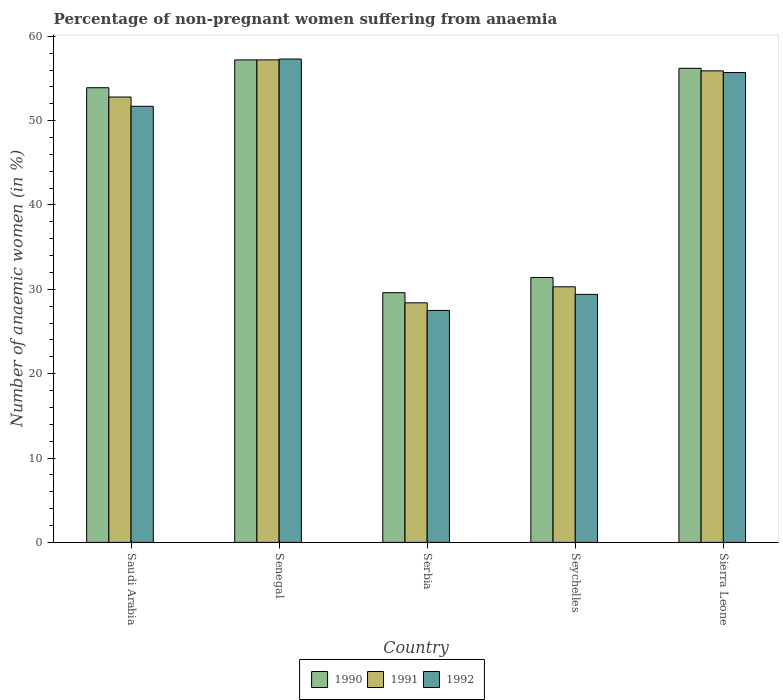Are the number of bars per tick equal to the number of legend labels?
Your response must be concise. Yes. How many bars are there on the 5th tick from the left?
Offer a very short reply. 3. How many bars are there on the 2nd tick from the right?
Your answer should be very brief. 3. What is the label of the 4th group of bars from the left?
Give a very brief answer. Seychelles. What is the percentage of non-pregnant women suffering from anaemia in 1992 in Senegal?
Offer a terse response. 57.3. Across all countries, what is the maximum percentage of non-pregnant women suffering from anaemia in 1991?
Give a very brief answer. 57.2. Across all countries, what is the minimum percentage of non-pregnant women suffering from anaemia in 1990?
Provide a succinct answer. 29.6. In which country was the percentage of non-pregnant women suffering from anaemia in 1990 maximum?
Ensure brevity in your answer.  Senegal. In which country was the percentage of non-pregnant women suffering from anaemia in 1992 minimum?
Offer a terse response. Serbia. What is the total percentage of non-pregnant women suffering from anaemia in 1992 in the graph?
Give a very brief answer. 221.6. What is the difference between the percentage of non-pregnant women suffering from anaemia in 1992 in Saudi Arabia and that in Serbia?
Your answer should be very brief. 24.2. What is the average percentage of non-pregnant women suffering from anaemia in 1992 per country?
Your answer should be compact. 44.32. What is the difference between the percentage of non-pregnant women suffering from anaemia of/in 1992 and percentage of non-pregnant women suffering from anaemia of/in 1991 in Saudi Arabia?
Give a very brief answer. -1.1. What is the ratio of the percentage of non-pregnant women suffering from anaemia in 1991 in Saudi Arabia to that in Sierra Leone?
Your response must be concise. 0.94. Is the difference between the percentage of non-pregnant women suffering from anaemia in 1992 in Saudi Arabia and Serbia greater than the difference between the percentage of non-pregnant women suffering from anaemia in 1991 in Saudi Arabia and Serbia?
Ensure brevity in your answer.  No. What is the difference between the highest and the second highest percentage of non-pregnant women suffering from anaemia in 1992?
Make the answer very short. 5.6. What is the difference between the highest and the lowest percentage of non-pregnant women suffering from anaemia in 1990?
Give a very brief answer. 27.6. Is the sum of the percentage of non-pregnant women suffering from anaemia in 1992 in Senegal and Seychelles greater than the maximum percentage of non-pregnant women suffering from anaemia in 1991 across all countries?
Make the answer very short. Yes. What does the 2nd bar from the right in Senegal represents?
Ensure brevity in your answer.  1991. Is it the case that in every country, the sum of the percentage of non-pregnant women suffering from anaemia in 1991 and percentage of non-pregnant women suffering from anaemia in 1990 is greater than the percentage of non-pregnant women suffering from anaemia in 1992?
Your answer should be very brief. Yes. How many bars are there?
Give a very brief answer. 15. How many countries are there in the graph?
Give a very brief answer. 5. What is the difference between two consecutive major ticks on the Y-axis?
Your answer should be very brief. 10. Are the values on the major ticks of Y-axis written in scientific E-notation?
Offer a very short reply. No. What is the title of the graph?
Give a very brief answer. Percentage of non-pregnant women suffering from anaemia. Does "1975" appear as one of the legend labels in the graph?
Ensure brevity in your answer.  No. What is the label or title of the X-axis?
Provide a succinct answer. Country. What is the label or title of the Y-axis?
Give a very brief answer. Number of anaemic women (in %). What is the Number of anaemic women (in %) in 1990 in Saudi Arabia?
Make the answer very short. 53.9. What is the Number of anaemic women (in %) of 1991 in Saudi Arabia?
Give a very brief answer. 52.8. What is the Number of anaemic women (in %) of 1992 in Saudi Arabia?
Provide a succinct answer. 51.7. What is the Number of anaemic women (in %) in 1990 in Senegal?
Ensure brevity in your answer.  57.2. What is the Number of anaemic women (in %) in 1991 in Senegal?
Your response must be concise. 57.2. What is the Number of anaemic women (in %) in 1992 in Senegal?
Provide a short and direct response. 57.3. What is the Number of anaemic women (in %) in 1990 in Serbia?
Your answer should be compact. 29.6. What is the Number of anaemic women (in %) of 1991 in Serbia?
Give a very brief answer. 28.4. What is the Number of anaemic women (in %) of 1992 in Serbia?
Keep it short and to the point. 27.5. What is the Number of anaemic women (in %) in 1990 in Seychelles?
Make the answer very short. 31.4. What is the Number of anaemic women (in %) of 1991 in Seychelles?
Offer a very short reply. 30.3. What is the Number of anaemic women (in %) of 1992 in Seychelles?
Offer a terse response. 29.4. What is the Number of anaemic women (in %) in 1990 in Sierra Leone?
Give a very brief answer. 56.2. What is the Number of anaemic women (in %) in 1991 in Sierra Leone?
Keep it short and to the point. 55.9. What is the Number of anaemic women (in %) in 1992 in Sierra Leone?
Your response must be concise. 55.7. Across all countries, what is the maximum Number of anaemic women (in %) in 1990?
Offer a very short reply. 57.2. Across all countries, what is the maximum Number of anaemic women (in %) of 1991?
Your response must be concise. 57.2. Across all countries, what is the maximum Number of anaemic women (in %) of 1992?
Your response must be concise. 57.3. Across all countries, what is the minimum Number of anaemic women (in %) of 1990?
Your answer should be very brief. 29.6. Across all countries, what is the minimum Number of anaemic women (in %) of 1991?
Offer a very short reply. 28.4. Across all countries, what is the minimum Number of anaemic women (in %) in 1992?
Give a very brief answer. 27.5. What is the total Number of anaemic women (in %) in 1990 in the graph?
Your answer should be compact. 228.3. What is the total Number of anaemic women (in %) of 1991 in the graph?
Your answer should be compact. 224.6. What is the total Number of anaemic women (in %) in 1992 in the graph?
Provide a succinct answer. 221.6. What is the difference between the Number of anaemic women (in %) in 1990 in Saudi Arabia and that in Senegal?
Keep it short and to the point. -3.3. What is the difference between the Number of anaemic women (in %) of 1991 in Saudi Arabia and that in Senegal?
Your response must be concise. -4.4. What is the difference between the Number of anaemic women (in %) of 1990 in Saudi Arabia and that in Serbia?
Offer a terse response. 24.3. What is the difference between the Number of anaemic women (in %) of 1991 in Saudi Arabia and that in Serbia?
Your answer should be very brief. 24.4. What is the difference between the Number of anaemic women (in %) of 1992 in Saudi Arabia and that in Serbia?
Ensure brevity in your answer.  24.2. What is the difference between the Number of anaemic women (in %) of 1990 in Saudi Arabia and that in Seychelles?
Your answer should be compact. 22.5. What is the difference between the Number of anaemic women (in %) of 1992 in Saudi Arabia and that in Seychelles?
Ensure brevity in your answer.  22.3. What is the difference between the Number of anaemic women (in %) of 1990 in Senegal and that in Serbia?
Your response must be concise. 27.6. What is the difference between the Number of anaemic women (in %) of 1991 in Senegal and that in Serbia?
Provide a short and direct response. 28.8. What is the difference between the Number of anaemic women (in %) in 1992 in Senegal and that in Serbia?
Make the answer very short. 29.8. What is the difference between the Number of anaemic women (in %) of 1990 in Senegal and that in Seychelles?
Offer a terse response. 25.8. What is the difference between the Number of anaemic women (in %) of 1991 in Senegal and that in Seychelles?
Your response must be concise. 26.9. What is the difference between the Number of anaemic women (in %) of 1992 in Senegal and that in Seychelles?
Provide a succinct answer. 27.9. What is the difference between the Number of anaemic women (in %) of 1990 in Senegal and that in Sierra Leone?
Give a very brief answer. 1. What is the difference between the Number of anaemic women (in %) in 1991 in Senegal and that in Sierra Leone?
Offer a terse response. 1.3. What is the difference between the Number of anaemic women (in %) of 1990 in Serbia and that in Seychelles?
Provide a short and direct response. -1.8. What is the difference between the Number of anaemic women (in %) of 1992 in Serbia and that in Seychelles?
Your answer should be compact. -1.9. What is the difference between the Number of anaemic women (in %) in 1990 in Serbia and that in Sierra Leone?
Offer a terse response. -26.6. What is the difference between the Number of anaemic women (in %) of 1991 in Serbia and that in Sierra Leone?
Make the answer very short. -27.5. What is the difference between the Number of anaemic women (in %) of 1992 in Serbia and that in Sierra Leone?
Make the answer very short. -28.2. What is the difference between the Number of anaemic women (in %) of 1990 in Seychelles and that in Sierra Leone?
Your response must be concise. -24.8. What is the difference between the Number of anaemic women (in %) in 1991 in Seychelles and that in Sierra Leone?
Offer a very short reply. -25.6. What is the difference between the Number of anaemic women (in %) in 1992 in Seychelles and that in Sierra Leone?
Your response must be concise. -26.3. What is the difference between the Number of anaemic women (in %) of 1990 in Saudi Arabia and the Number of anaemic women (in %) of 1992 in Senegal?
Your response must be concise. -3.4. What is the difference between the Number of anaemic women (in %) of 1991 in Saudi Arabia and the Number of anaemic women (in %) of 1992 in Senegal?
Provide a succinct answer. -4.5. What is the difference between the Number of anaemic women (in %) in 1990 in Saudi Arabia and the Number of anaemic women (in %) in 1991 in Serbia?
Keep it short and to the point. 25.5. What is the difference between the Number of anaemic women (in %) of 1990 in Saudi Arabia and the Number of anaemic women (in %) of 1992 in Serbia?
Your answer should be very brief. 26.4. What is the difference between the Number of anaemic women (in %) of 1991 in Saudi Arabia and the Number of anaemic women (in %) of 1992 in Serbia?
Your answer should be very brief. 25.3. What is the difference between the Number of anaemic women (in %) of 1990 in Saudi Arabia and the Number of anaemic women (in %) of 1991 in Seychelles?
Your answer should be very brief. 23.6. What is the difference between the Number of anaemic women (in %) in 1990 in Saudi Arabia and the Number of anaemic women (in %) in 1992 in Seychelles?
Keep it short and to the point. 24.5. What is the difference between the Number of anaemic women (in %) of 1991 in Saudi Arabia and the Number of anaemic women (in %) of 1992 in Seychelles?
Give a very brief answer. 23.4. What is the difference between the Number of anaemic women (in %) in 1990 in Saudi Arabia and the Number of anaemic women (in %) in 1992 in Sierra Leone?
Your answer should be very brief. -1.8. What is the difference between the Number of anaemic women (in %) in 1991 in Saudi Arabia and the Number of anaemic women (in %) in 1992 in Sierra Leone?
Make the answer very short. -2.9. What is the difference between the Number of anaemic women (in %) of 1990 in Senegal and the Number of anaemic women (in %) of 1991 in Serbia?
Your response must be concise. 28.8. What is the difference between the Number of anaemic women (in %) in 1990 in Senegal and the Number of anaemic women (in %) in 1992 in Serbia?
Your response must be concise. 29.7. What is the difference between the Number of anaemic women (in %) of 1991 in Senegal and the Number of anaemic women (in %) of 1992 in Serbia?
Keep it short and to the point. 29.7. What is the difference between the Number of anaemic women (in %) in 1990 in Senegal and the Number of anaemic women (in %) in 1991 in Seychelles?
Give a very brief answer. 26.9. What is the difference between the Number of anaemic women (in %) of 1990 in Senegal and the Number of anaemic women (in %) of 1992 in Seychelles?
Ensure brevity in your answer.  27.8. What is the difference between the Number of anaemic women (in %) of 1991 in Senegal and the Number of anaemic women (in %) of 1992 in Seychelles?
Keep it short and to the point. 27.8. What is the difference between the Number of anaemic women (in %) of 1990 in Senegal and the Number of anaemic women (in %) of 1991 in Sierra Leone?
Give a very brief answer. 1.3. What is the difference between the Number of anaemic women (in %) in 1991 in Senegal and the Number of anaemic women (in %) in 1992 in Sierra Leone?
Provide a succinct answer. 1.5. What is the difference between the Number of anaemic women (in %) of 1991 in Serbia and the Number of anaemic women (in %) of 1992 in Seychelles?
Keep it short and to the point. -1. What is the difference between the Number of anaemic women (in %) of 1990 in Serbia and the Number of anaemic women (in %) of 1991 in Sierra Leone?
Provide a short and direct response. -26.3. What is the difference between the Number of anaemic women (in %) of 1990 in Serbia and the Number of anaemic women (in %) of 1992 in Sierra Leone?
Offer a terse response. -26.1. What is the difference between the Number of anaemic women (in %) in 1991 in Serbia and the Number of anaemic women (in %) in 1992 in Sierra Leone?
Your answer should be compact. -27.3. What is the difference between the Number of anaemic women (in %) in 1990 in Seychelles and the Number of anaemic women (in %) in 1991 in Sierra Leone?
Give a very brief answer. -24.5. What is the difference between the Number of anaemic women (in %) of 1990 in Seychelles and the Number of anaemic women (in %) of 1992 in Sierra Leone?
Keep it short and to the point. -24.3. What is the difference between the Number of anaemic women (in %) in 1991 in Seychelles and the Number of anaemic women (in %) in 1992 in Sierra Leone?
Your answer should be very brief. -25.4. What is the average Number of anaemic women (in %) of 1990 per country?
Offer a very short reply. 45.66. What is the average Number of anaemic women (in %) in 1991 per country?
Provide a succinct answer. 44.92. What is the average Number of anaemic women (in %) in 1992 per country?
Your response must be concise. 44.32. What is the difference between the Number of anaemic women (in %) of 1990 and Number of anaemic women (in %) of 1991 in Saudi Arabia?
Provide a succinct answer. 1.1. What is the difference between the Number of anaemic women (in %) in 1990 and Number of anaemic women (in %) in 1991 in Serbia?
Ensure brevity in your answer.  1.2. What is the difference between the Number of anaemic women (in %) in 1991 and Number of anaemic women (in %) in 1992 in Serbia?
Offer a very short reply. 0.9. What is the difference between the Number of anaemic women (in %) in 1990 and Number of anaemic women (in %) in 1992 in Seychelles?
Your response must be concise. 2. What is the difference between the Number of anaemic women (in %) of 1990 and Number of anaemic women (in %) of 1992 in Sierra Leone?
Provide a succinct answer. 0.5. What is the difference between the Number of anaemic women (in %) in 1991 and Number of anaemic women (in %) in 1992 in Sierra Leone?
Your answer should be very brief. 0.2. What is the ratio of the Number of anaemic women (in %) of 1990 in Saudi Arabia to that in Senegal?
Provide a short and direct response. 0.94. What is the ratio of the Number of anaemic women (in %) of 1992 in Saudi Arabia to that in Senegal?
Your answer should be very brief. 0.9. What is the ratio of the Number of anaemic women (in %) of 1990 in Saudi Arabia to that in Serbia?
Ensure brevity in your answer.  1.82. What is the ratio of the Number of anaemic women (in %) in 1991 in Saudi Arabia to that in Serbia?
Ensure brevity in your answer.  1.86. What is the ratio of the Number of anaemic women (in %) in 1992 in Saudi Arabia to that in Serbia?
Offer a very short reply. 1.88. What is the ratio of the Number of anaemic women (in %) of 1990 in Saudi Arabia to that in Seychelles?
Your response must be concise. 1.72. What is the ratio of the Number of anaemic women (in %) of 1991 in Saudi Arabia to that in Seychelles?
Your answer should be very brief. 1.74. What is the ratio of the Number of anaemic women (in %) in 1992 in Saudi Arabia to that in Seychelles?
Your response must be concise. 1.76. What is the ratio of the Number of anaemic women (in %) of 1990 in Saudi Arabia to that in Sierra Leone?
Your answer should be compact. 0.96. What is the ratio of the Number of anaemic women (in %) in 1991 in Saudi Arabia to that in Sierra Leone?
Keep it short and to the point. 0.94. What is the ratio of the Number of anaemic women (in %) of 1992 in Saudi Arabia to that in Sierra Leone?
Keep it short and to the point. 0.93. What is the ratio of the Number of anaemic women (in %) of 1990 in Senegal to that in Serbia?
Your answer should be very brief. 1.93. What is the ratio of the Number of anaemic women (in %) in 1991 in Senegal to that in Serbia?
Provide a short and direct response. 2.01. What is the ratio of the Number of anaemic women (in %) in 1992 in Senegal to that in Serbia?
Ensure brevity in your answer.  2.08. What is the ratio of the Number of anaemic women (in %) of 1990 in Senegal to that in Seychelles?
Provide a succinct answer. 1.82. What is the ratio of the Number of anaemic women (in %) of 1991 in Senegal to that in Seychelles?
Your response must be concise. 1.89. What is the ratio of the Number of anaemic women (in %) in 1992 in Senegal to that in Seychelles?
Give a very brief answer. 1.95. What is the ratio of the Number of anaemic women (in %) in 1990 in Senegal to that in Sierra Leone?
Provide a succinct answer. 1.02. What is the ratio of the Number of anaemic women (in %) in 1991 in Senegal to that in Sierra Leone?
Keep it short and to the point. 1.02. What is the ratio of the Number of anaemic women (in %) in 1992 in Senegal to that in Sierra Leone?
Ensure brevity in your answer.  1.03. What is the ratio of the Number of anaemic women (in %) of 1990 in Serbia to that in Seychelles?
Provide a succinct answer. 0.94. What is the ratio of the Number of anaemic women (in %) of 1991 in Serbia to that in Seychelles?
Your answer should be very brief. 0.94. What is the ratio of the Number of anaemic women (in %) of 1992 in Serbia to that in Seychelles?
Your answer should be compact. 0.94. What is the ratio of the Number of anaemic women (in %) in 1990 in Serbia to that in Sierra Leone?
Provide a succinct answer. 0.53. What is the ratio of the Number of anaemic women (in %) of 1991 in Serbia to that in Sierra Leone?
Your response must be concise. 0.51. What is the ratio of the Number of anaemic women (in %) of 1992 in Serbia to that in Sierra Leone?
Provide a succinct answer. 0.49. What is the ratio of the Number of anaemic women (in %) in 1990 in Seychelles to that in Sierra Leone?
Your response must be concise. 0.56. What is the ratio of the Number of anaemic women (in %) of 1991 in Seychelles to that in Sierra Leone?
Your response must be concise. 0.54. What is the ratio of the Number of anaemic women (in %) in 1992 in Seychelles to that in Sierra Leone?
Your answer should be very brief. 0.53. What is the difference between the highest and the second highest Number of anaemic women (in %) in 1991?
Provide a short and direct response. 1.3. What is the difference between the highest and the lowest Number of anaemic women (in %) of 1990?
Offer a very short reply. 27.6. What is the difference between the highest and the lowest Number of anaemic women (in %) of 1991?
Offer a very short reply. 28.8. What is the difference between the highest and the lowest Number of anaemic women (in %) of 1992?
Ensure brevity in your answer.  29.8. 